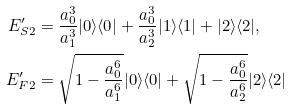Convert formula to latex. <formula><loc_0><loc_0><loc_500><loc_500>E ^ { \prime } _ { S 2 } & = \frac { a _ { 0 } ^ { 3 } } { a _ { 1 } ^ { 3 } } | 0 \rangle \langle 0 | + \frac { a _ { 0 } ^ { 3 } } { a _ { 2 } ^ { 3 } } | 1 \rangle \langle 1 | + | 2 \rangle \langle 2 | , \\ E ^ { \prime } _ { F 2 } & = \sqrt { 1 - \frac { a _ { 0 } ^ { 6 } } { a _ { 1 } ^ { 6 } } } | 0 \rangle \langle 0 | + \sqrt { 1 - \frac { a _ { 0 } ^ { 6 } } { a _ { 2 } ^ { 6 } } } | 2 \rangle \langle 2 |</formula> 